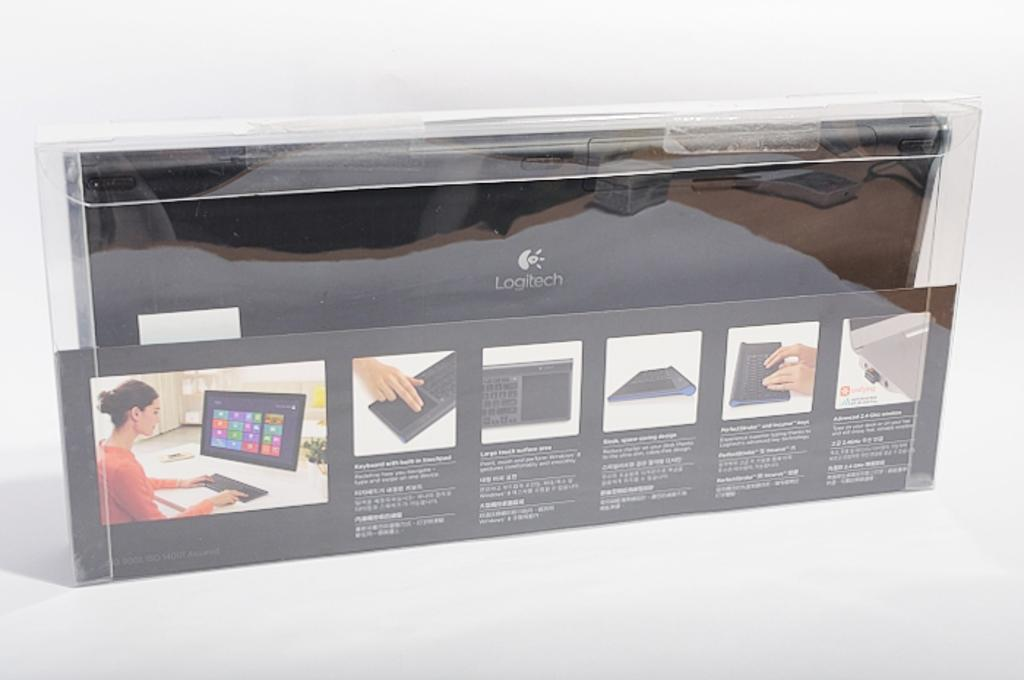<image>
Create a compact narrative representing the image presented. Computer Monitor and Keyboard from Logitech that comes in a case. 